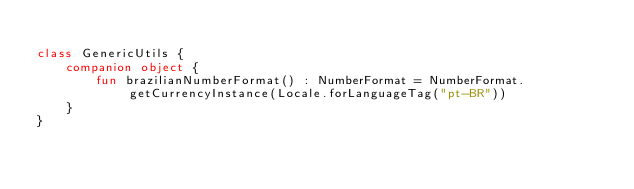<code> <loc_0><loc_0><loc_500><loc_500><_Kotlin_>
class GenericUtils {
    companion object {
        fun brazilianNumberFormat() : NumberFormat = NumberFormat.getCurrencyInstance(Locale.forLanguageTag("pt-BR"))
    }
}</code> 